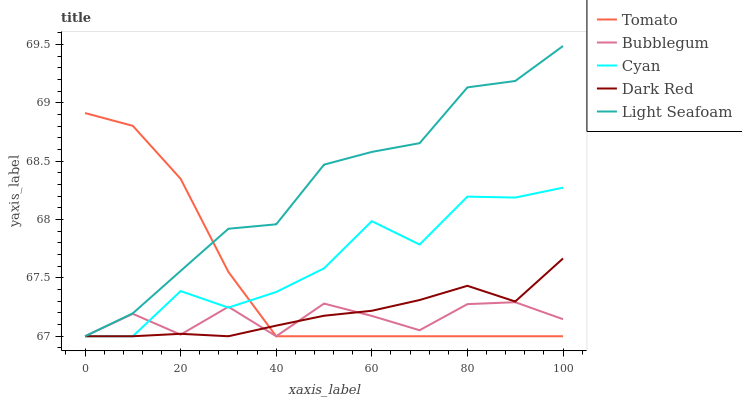Does Cyan have the minimum area under the curve?
Answer yes or no. No. Does Cyan have the maximum area under the curve?
Answer yes or no. No. Is Light Seafoam the smoothest?
Answer yes or no. No. Is Light Seafoam the roughest?
Answer yes or no. No. Does Cyan have the highest value?
Answer yes or no. No. 